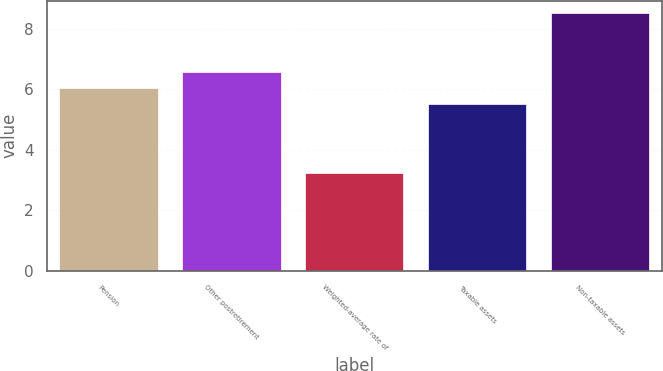Convert chart. <chart><loc_0><loc_0><loc_500><loc_500><bar_chart><fcel>Pension<fcel>Other postretirement<fcel>Weighted-average rate of<fcel>Taxable assets<fcel>Non-taxable assets<nl><fcel>6.03<fcel>6.56<fcel>3.25<fcel>5.5<fcel>8.5<nl></chart> 